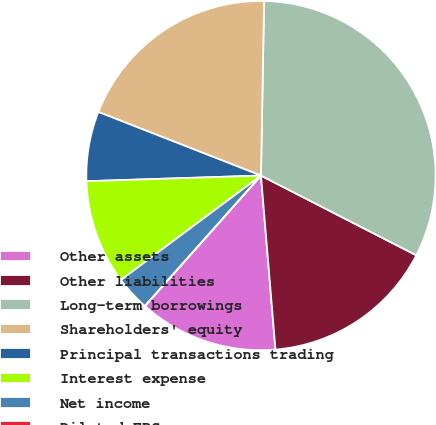Convert chart. <chart><loc_0><loc_0><loc_500><loc_500><pie_chart><fcel>Other assets<fcel>Other liabilities<fcel>Long-term borrowings<fcel>Shareholders' equity<fcel>Principal transactions trading<fcel>Interest expense<fcel>Net income<fcel>Diluted EPS<nl><fcel>12.9%<fcel>16.13%<fcel>32.26%<fcel>19.35%<fcel>6.45%<fcel>9.68%<fcel>3.23%<fcel>0.0%<nl></chart> 